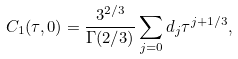Convert formula to latex. <formula><loc_0><loc_0><loc_500><loc_500>C _ { 1 } ( \tau , 0 ) = \frac { 3 ^ { 2 / 3 } } { \Gamma ( 2 / 3 ) } \sum _ { j = 0 } d _ { j } \tau ^ { j + 1 / 3 } ,</formula> 